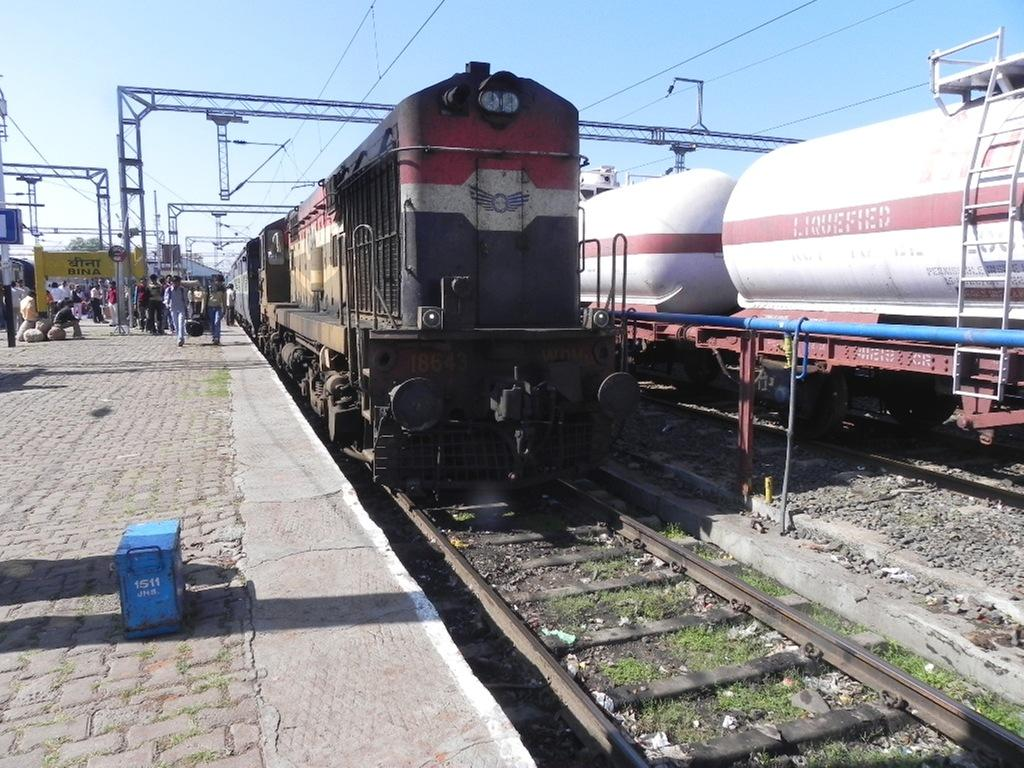What can be seen in the background of the image? The sky is visible in the background of the image. What type of vehicles are in the image? There are trains in the image. What is the surface on which the trains are running? Train tracks are present in the image. What type of vegetation is visible in the image? Grass is visible in the image. What type of ground surface is present in the image? Stones are present in the image. What structure is in the image for passengers to wait or board the trains? There is a platform in the image. What are the people in the image doing? People are present in the image. What type of signage or information boards are visible in the image? Boards are visible in the image. What type of infrastructure is present to support electrical or communication systems? Wires are present in the image. What type of vertical structures are visible in the image? Poles are visible in the image. What type of objects can be seen in the image? There are objects in the image. Can you tell me how many horses are present in the image? There are no horses present in the image. What type of desk can be seen in the image? There is no desk present in the image. Are there any skateboards visible in the image? There are no skateboards present in the image. 